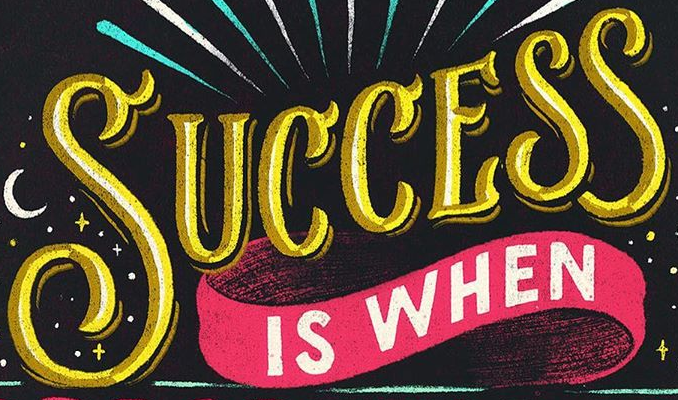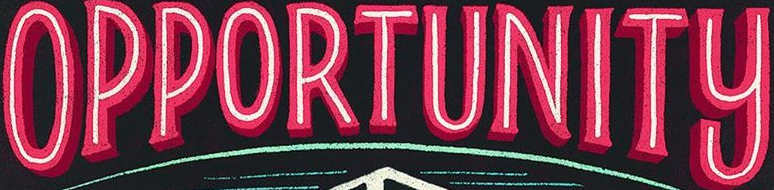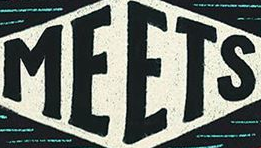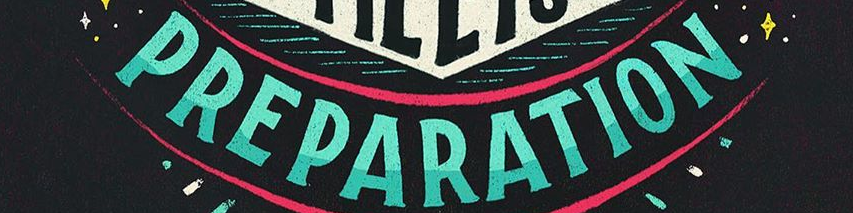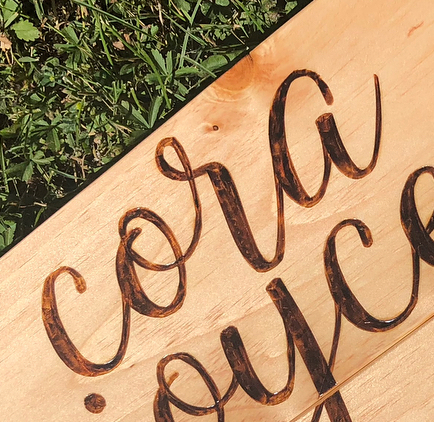What words are shown in these images in order, separated by a semicolon? SUCCESS; OPPORTUNITY; MEETS; PREPARATION; cora 